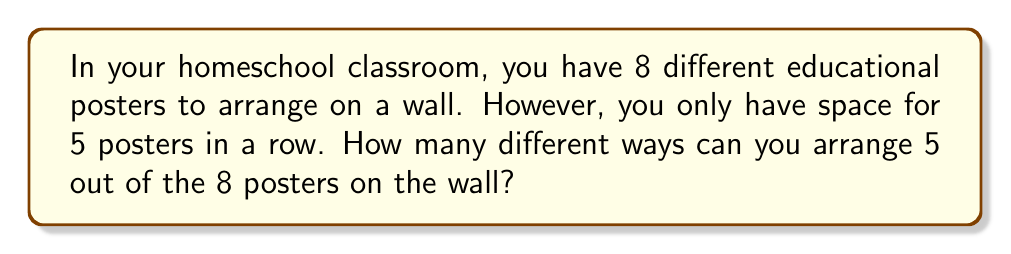Can you answer this question? Let's approach this step-by-step:

1) This is a permutation problem because the order of the posters matters (arranging them in a row).

2) We are selecting 5 posters out of 8 and arranging them.

3) The formula for permutations without repetition is:

   $$P(n,r) = \frac{n!}{(n-r)!}$$

   Where $n$ is the total number of items to choose from, and $r$ is the number of items being chosen.

4) In this case, $n = 8$ (total posters) and $r = 5$ (posters to be arranged).

5) Let's substitute these values into our formula:

   $$P(8,5) = \frac{8!}{(8-5)!} = \frac{8!}{3!}$$

6) Expand this:
   $$\frac{8 \times 7 \times 6 \times 5 \times 4 \times 3!}{3!}$$

7) The $3!$ cancels out in the numerator and denominator:

   $$8 \times 7 \times 6 \times 5 \times 4 = 6720$$

Therefore, there are 6720 different ways to arrange 5 out of the 8 posters on the wall.
Answer: 6720 